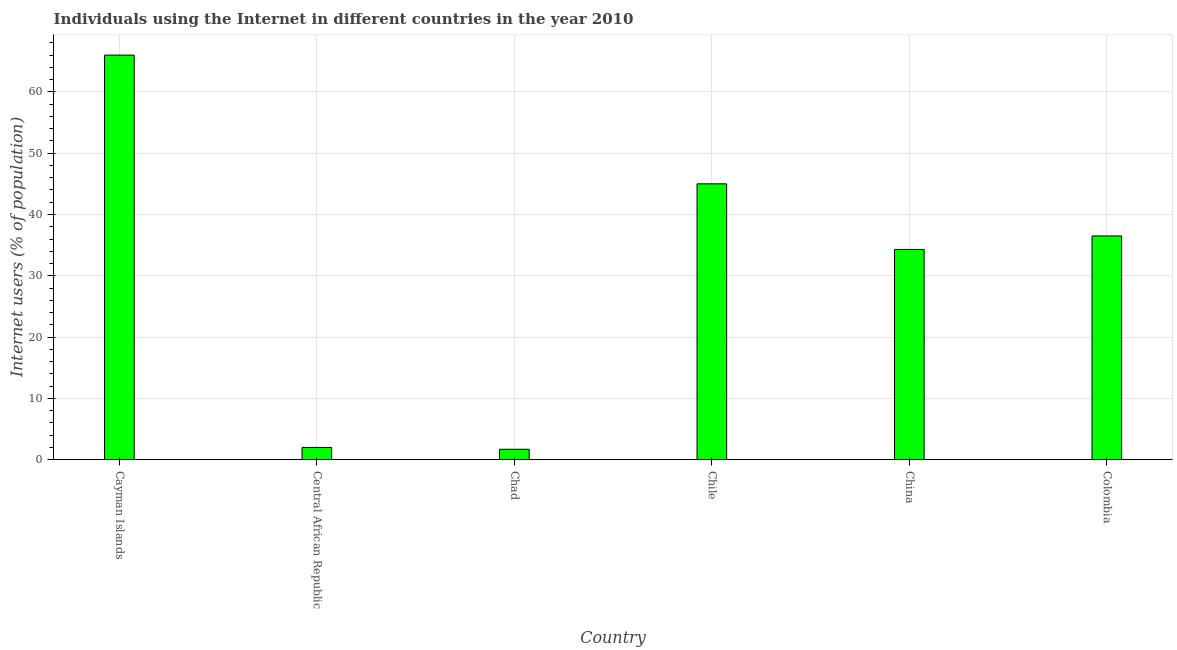Does the graph contain any zero values?
Keep it short and to the point. No. Does the graph contain grids?
Your answer should be very brief. Yes. What is the title of the graph?
Offer a very short reply. Individuals using the Internet in different countries in the year 2010. What is the label or title of the Y-axis?
Your response must be concise. Internet users (% of population). What is the number of internet users in Central African Republic?
Make the answer very short. 2. Across all countries, what is the minimum number of internet users?
Your response must be concise. 1.7. In which country was the number of internet users maximum?
Provide a short and direct response. Cayman Islands. In which country was the number of internet users minimum?
Your response must be concise. Chad. What is the sum of the number of internet users?
Ensure brevity in your answer.  185.5. What is the average number of internet users per country?
Make the answer very short. 30.92. What is the median number of internet users?
Your response must be concise. 35.4. What is the ratio of the number of internet users in Chile to that in China?
Provide a short and direct response. 1.31. Is the difference between the number of internet users in Chad and Colombia greater than the difference between any two countries?
Provide a short and direct response. No. What is the difference between the highest and the second highest number of internet users?
Your answer should be compact. 21. What is the difference between the highest and the lowest number of internet users?
Give a very brief answer. 64.3. In how many countries, is the number of internet users greater than the average number of internet users taken over all countries?
Provide a succinct answer. 4. How many bars are there?
Make the answer very short. 6. Are all the bars in the graph horizontal?
Ensure brevity in your answer.  No. How many countries are there in the graph?
Give a very brief answer. 6. What is the difference between two consecutive major ticks on the Y-axis?
Offer a terse response. 10. Are the values on the major ticks of Y-axis written in scientific E-notation?
Offer a terse response. No. What is the Internet users (% of population) of China?
Make the answer very short. 34.3. What is the Internet users (% of population) in Colombia?
Your answer should be compact. 36.5. What is the difference between the Internet users (% of population) in Cayman Islands and Central African Republic?
Your response must be concise. 64. What is the difference between the Internet users (% of population) in Cayman Islands and Chad?
Your answer should be very brief. 64.3. What is the difference between the Internet users (% of population) in Cayman Islands and Chile?
Your answer should be very brief. 21. What is the difference between the Internet users (% of population) in Cayman Islands and China?
Your answer should be compact. 31.7. What is the difference between the Internet users (% of population) in Cayman Islands and Colombia?
Offer a very short reply. 29.5. What is the difference between the Internet users (% of population) in Central African Republic and Chad?
Keep it short and to the point. 0.3. What is the difference between the Internet users (% of population) in Central African Republic and Chile?
Your answer should be compact. -43. What is the difference between the Internet users (% of population) in Central African Republic and China?
Your response must be concise. -32.3. What is the difference between the Internet users (% of population) in Central African Republic and Colombia?
Keep it short and to the point. -34.5. What is the difference between the Internet users (% of population) in Chad and Chile?
Keep it short and to the point. -43.3. What is the difference between the Internet users (% of population) in Chad and China?
Provide a short and direct response. -32.6. What is the difference between the Internet users (% of population) in Chad and Colombia?
Ensure brevity in your answer.  -34.8. What is the difference between the Internet users (% of population) in Chile and China?
Your answer should be compact. 10.7. What is the difference between the Internet users (% of population) in Chile and Colombia?
Keep it short and to the point. 8.5. What is the ratio of the Internet users (% of population) in Cayman Islands to that in Central African Republic?
Your answer should be compact. 33. What is the ratio of the Internet users (% of population) in Cayman Islands to that in Chad?
Make the answer very short. 38.82. What is the ratio of the Internet users (% of population) in Cayman Islands to that in Chile?
Your response must be concise. 1.47. What is the ratio of the Internet users (% of population) in Cayman Islands to that in China?
Ensure brevity in your answer.  1.92. What is the ratio of the Internet users (% of population) in Cayman Islands to that in Colombia?
Offer a very short reply. 1.81. What is the ratio of the Internet users (% of population) in Central African Republic to that in Chad?
Offer a very short reply. 1.18. What is the ratio of the Internet users (% of population) in Central African Republic to that in Chile?
Your answer should be very brief. 0.04. What is the ratio of the Internet users (% of population) in Central African Republic to that in China?
Make the answer very short. 0.06. What is the ratio of the Internet users (% of population) in Central African Republic to that in Colombia?
Give a very brief answer. 0.06. What is the ratio of the Internet users (% of population) in Chad to that in Chile?
Offer a terse response. 0.04. What is the ratio of the Internet users (% of population) in Chad to that in Colombia?
Make the answer very short. 0.05. What is the ratio of the Internet users (% of population) in Chile to that in China?
Your response must be concise. 1.31. What is the ratio of the Internet users (% of population) in Chile to that in Colombia?
Provide a succinct answer. 1.23. What is the ratio of the Internet users (% of population) in China to that in Colombia?
Ensure brevity in your answer.  0.94. 